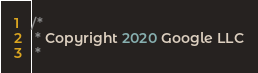<code> <loc_0><loc_0><loc_500><loc_500><_Java_>/*
 * Copyright 2020 Google LLC
 *</code> 